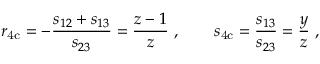<formula> <loc_0><loc_0><loc_500><loc_500>r _ { 4 c } = - \frac { s _ { 1 2 } + s _ { 1 3 } } { s _ { 2 3 } } = \frac { z - 1 } { z } \ , \quad s _ { 4 c } = \frac { s _ { 1 3 } } { s _ { 2 3 } } = \frac { y } { z } \, ,</formula> 